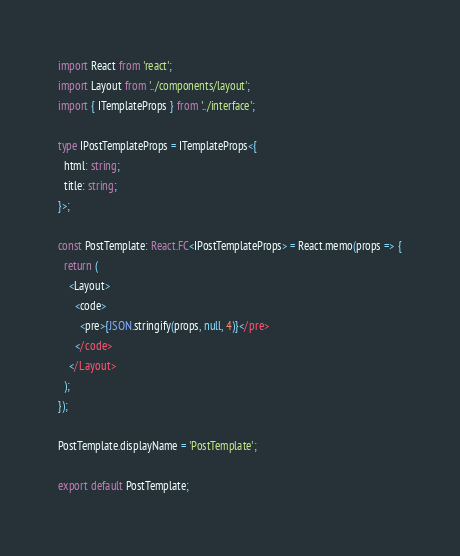Convert code to text. <code><loc_0><loc_0><loc_500><loc_500><_TypeScript_>import React from 'react';
import Layout from '../components/layout';
import { ITemplateProps } from '../interface';

type IPostTemplateProps = ITemplateProps<{
  html: string;
  title: string;
}>;

const PostTemplate: React.FC<IPostTemplateProps> = React.memo(props => {
  return (
    <Layout>
      <code>
        <pre>{JSON.stringify(props, null, 4)}</pre>
      </code>
    </Layout>
  );
});

PostTemplate.displayName = 'PostTemplate';

export default PostTemplate;</code> 